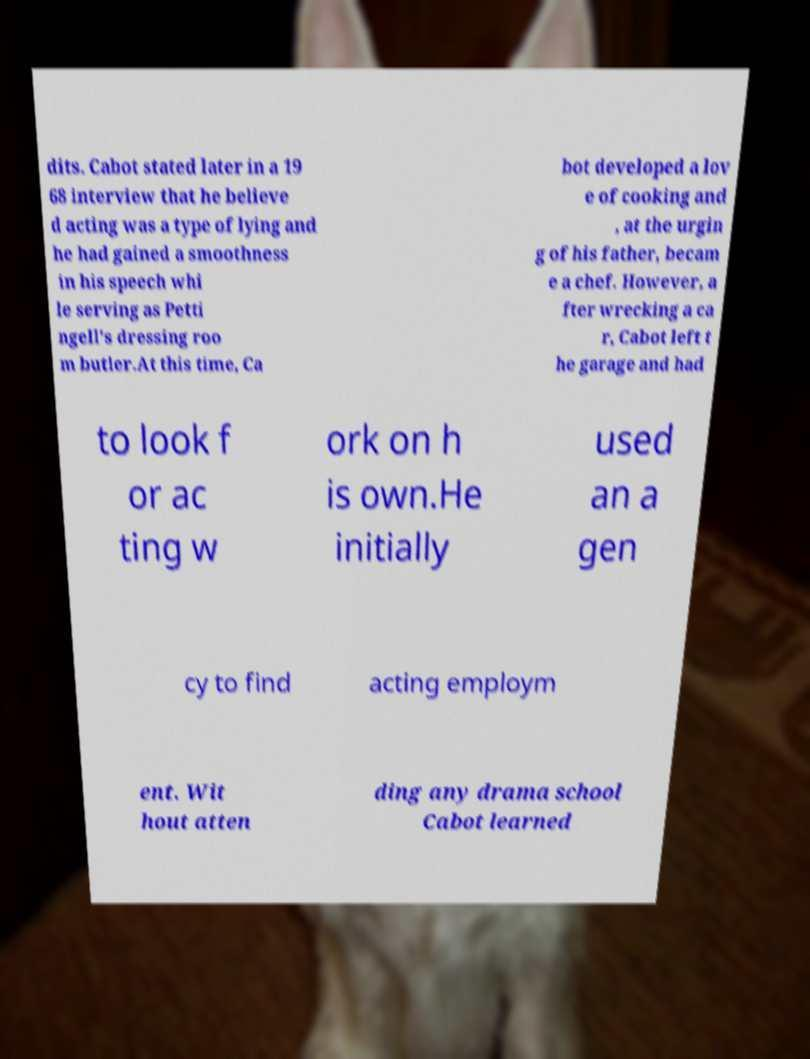For documentation purposes, I need the text within this image transcribed. Could you provide that? dits. Cabot stated later in a 19 68 interview that he believe d acting was a type of lying and he had gained a smoothness in his speech whi le serving as Petti ngell's dressing roo m butler.At this time, Ca bot developed a lov e of cooking and , at the urgin g of his father, becam e a chef. However, a fter wrecking a ca r, Cabot left t he garage and had to look f or ac ting w ork on h is own.He initially used an a gen cy to find acting employm ent. Wit hout atten ding any drama school Cabot learned 